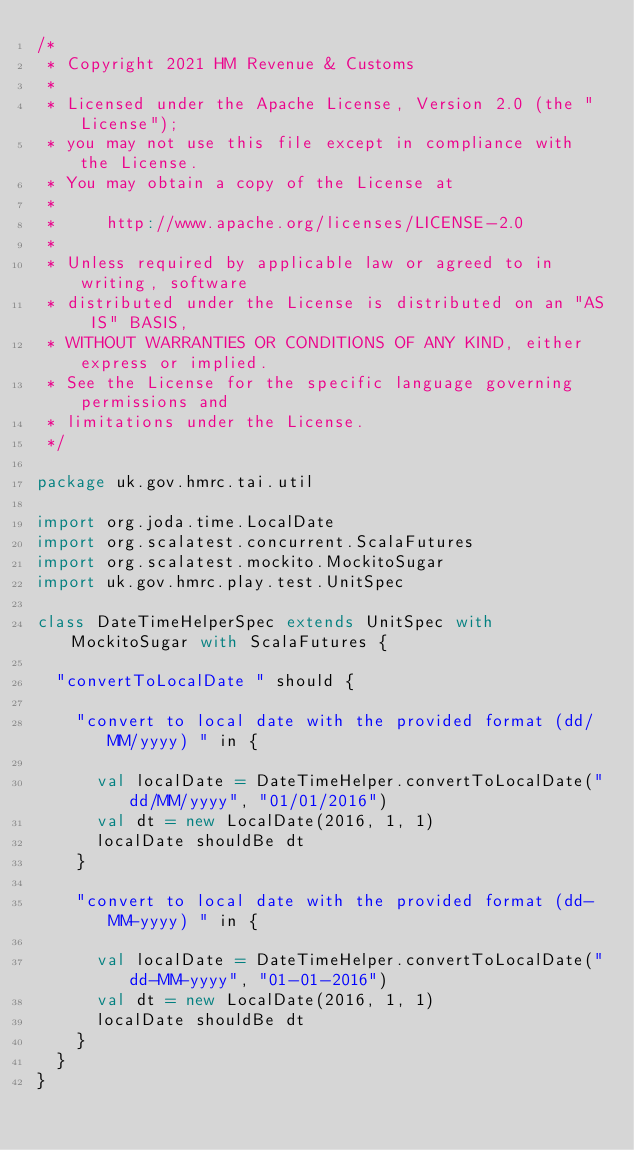Convert code to text. <code><loc_0><loc_0><loc_500><loc_500><_Scala_>/*
 * Copyright 2021 HM Revenue & Customs
 *
 * Licensed under the Apache License, Version 2.0 (the "License");
 * you may not use this file except in compliance with the License.
 * You may obtain a copy of the License at
 *
 *     http://www.apache.org/licenses/LICENSE-2.0
 *
 * Unless required by applicable law or agreed to in writing, software
 * distributed under the License is distributed on an "AS IS" BASIS,
 * WITHOUT WARRANTIES OR CONDITIONS OF ANY KIND, either express or implied.
 * See the License for the specific language governing permissions and
 * limitations under the License.
 */

package uk.gov.hmrc.tai.util

import org.joda.time.LocalDate
import org.scalatest.concurrent.ScalaFutures
import org.scalatest.mockito.MockitoSugar
import uk.gov.hmrc.play.test.UnitSpec

class DateTimeHelperSpec extends UnitSpec with MockitoSugar with ScalaFutures {

  "convertToLocalDate " should {

    "convert to local date with the provided format (dd/MM/yyyy) " in {

      val localDate = DateTimeHelper.convertToLocalDate("dd/MM/yyyy", "01/01/2016")
      val dt = new LocalDate(2016, 1, 1)
      localDate shouldBe dt
    }

    "convert to local date with the provided format (dd-MM-yyyy) " in {

      val localDate = DateTimeHelper.convertToLocalDate("dd-MM-yyyy", "01-01-2016")
      val dt = new LocalDate(2016, 1, 1)
      localDate shouldBe dt
    }
  }
}
</code> 